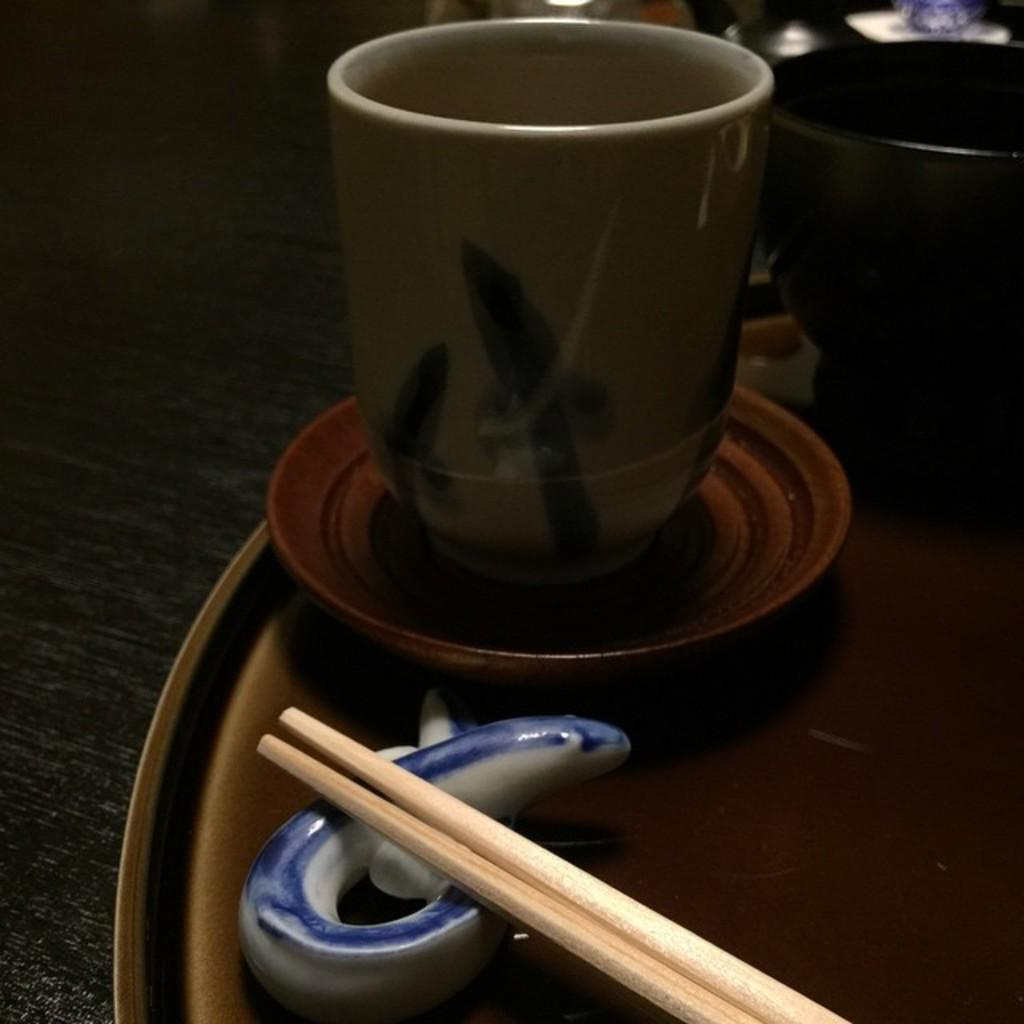What is present on the table in the image? There is a cup, a saucer, and a plate with two chopsticks in the image. What is the relationship between the cup and saucer? The cup and saucer are on a plate in the image. What type of utensils are included with the plate? There are two chopsticks in the plate. Where is the plate located? The plate is placed on a table in the image. What type of shade is covering the cup in the image? There is no shade covering the cup in the image; it is visible on the plate. 